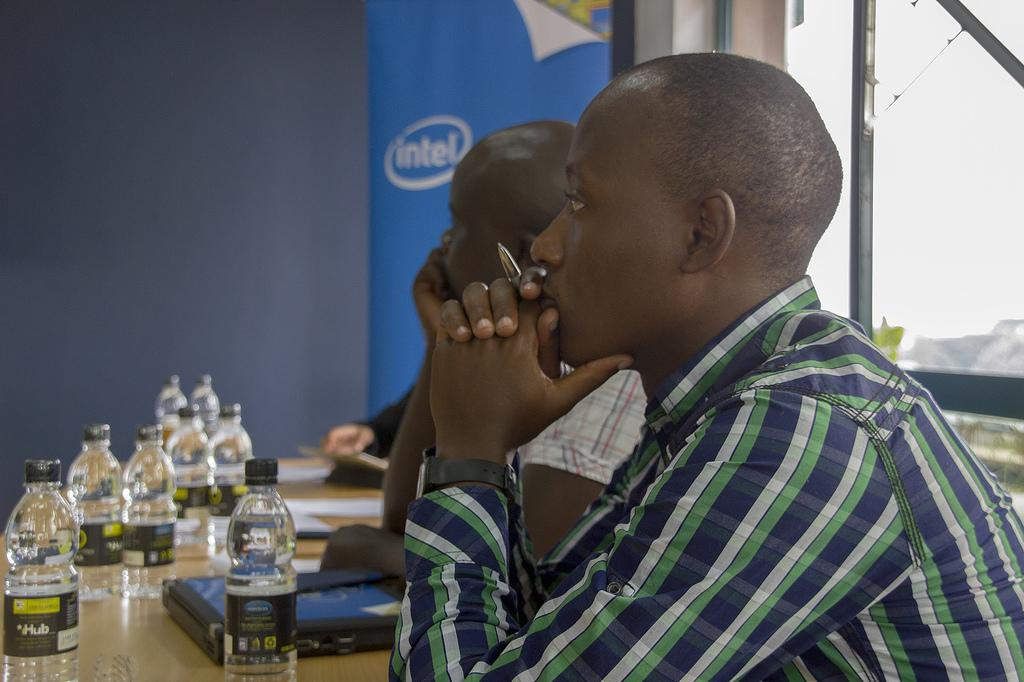What are the men in the image doing? The men are sitting at a table in the image. What items can be seen on the table? There are books, papers, and bottles on the table. What is visible in the background of the image? There is an advertisement and a wall in the background of the image. What type of polish is being applied to the table in the image? There is no polish being applied to the table in the image. What is the reaction of the men to the advertisement in the background? The image does not show the men's reactions to the advertisement in the background. 